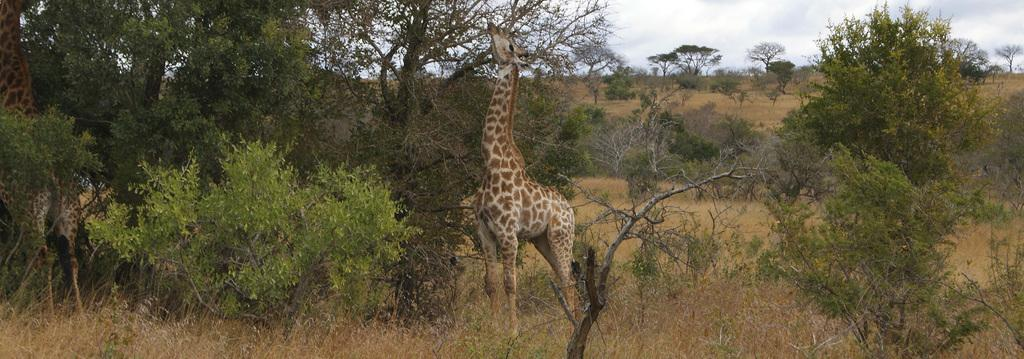Where was the image taken? The image was taken in a forest. What can be seen in the foreground of the image? There are trees, plants, grass, shrubs, and a giraffe in the foreground of the image. What is the background of the image? There are trees in the background of the image. What is the condition of the sky in the image? The sky is cloudy in the image. Can you see any shady spots under the trees for the toad to rest in the image? There is no toad present in the image, and the image does not provide information about shady spots under the trees. 